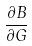Convert formula to latex. <formula><loc_0><loc_0><loc_500><loc_500>\frac { \partial B } { \partial G }</formula> 